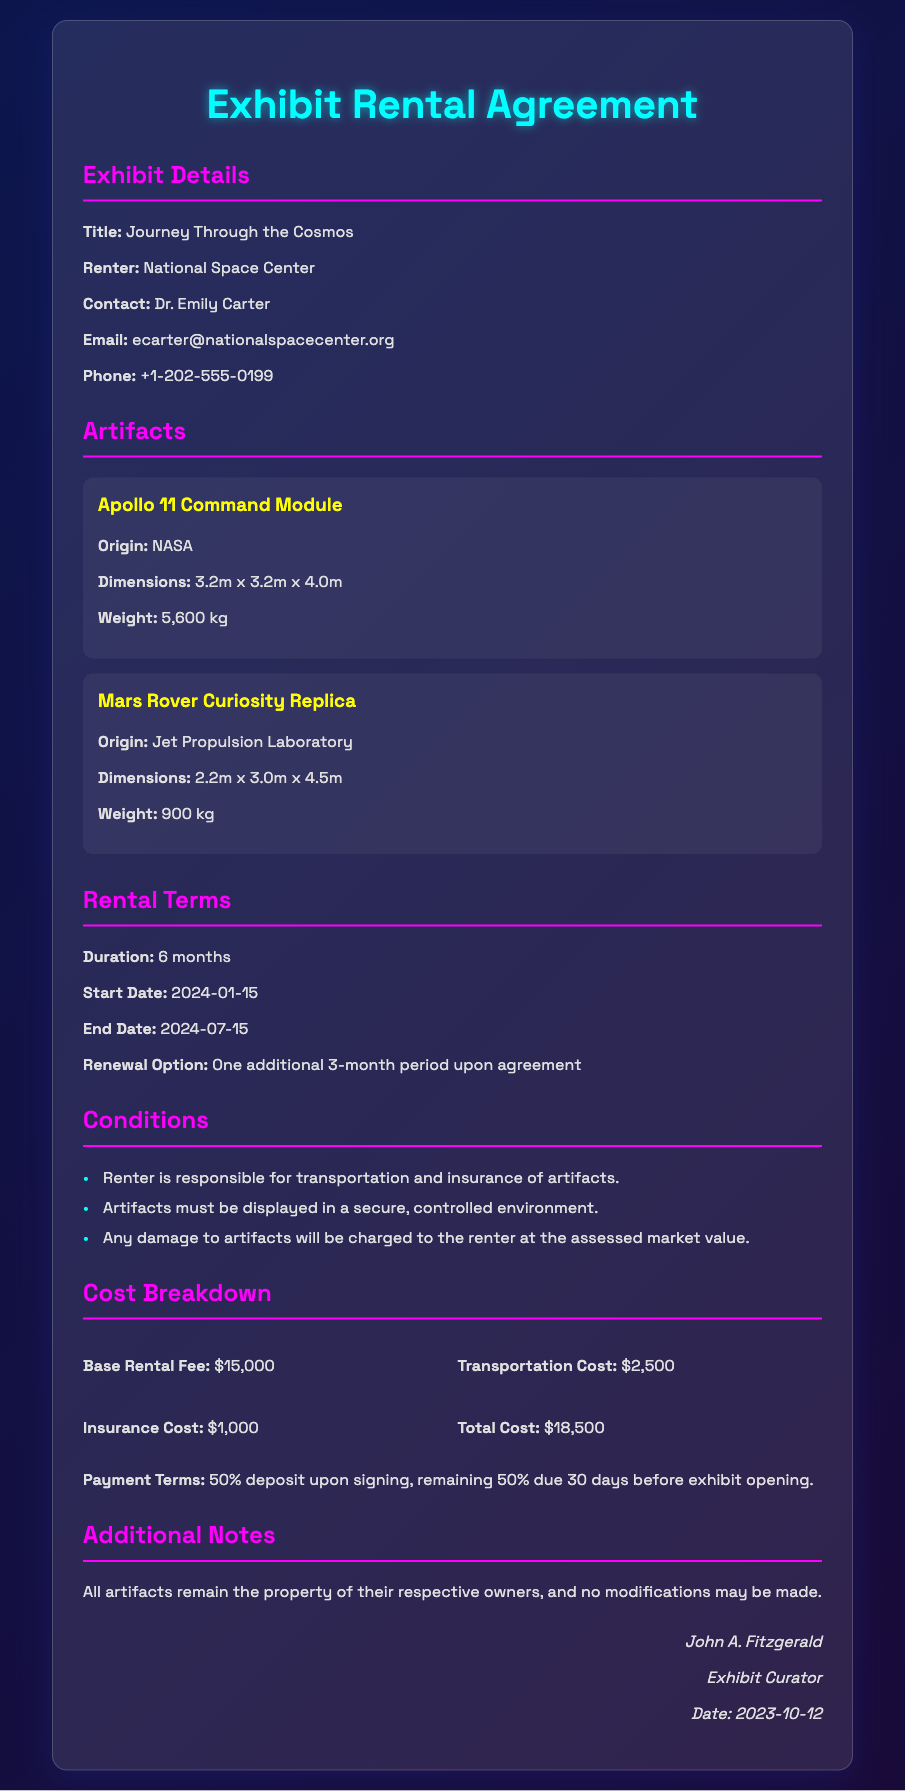what is the title of the exhibit? The title of the exhibit is explicitly stated in the document as "Journey Through the Cosmos."
Answer: Journey Through the Cosmos who is the renter of the exhibit? The document specifies that the renter is the "National Space Center."
Answer: National Space Center what is the total cost of the rental? The total cost is detailed in the cost breakdown section, which sums up the charges to $18,500.
Answer: $18,500 when does the rental period start? The start date is provided in the rental terms, and it is clearly marked as "2024-01-15."
Answer: 2024-01-15 how long is the initial rental duration? The document states that the rental duration is "6 months."
Answer: 6 months what is the insurance cost? The insurance cost is listed in the cost breakdown, amounting to "$1,000."
Answer: $1,000 what will happen if the artifacts are damaged? The conditions mention that any damage will charge the renter at the assessed market value.
Answer: Charged at assessed market value how many additional months can the rental period be renewed for? The renewal option states an additional "3-month period" can be agreed upon.
Answer: 3 months who is the contact person for the renter? The document identifies "Dr. Emily Carter" as the contact person for the National Space Center.
Answer: Dr. Emily Carter 